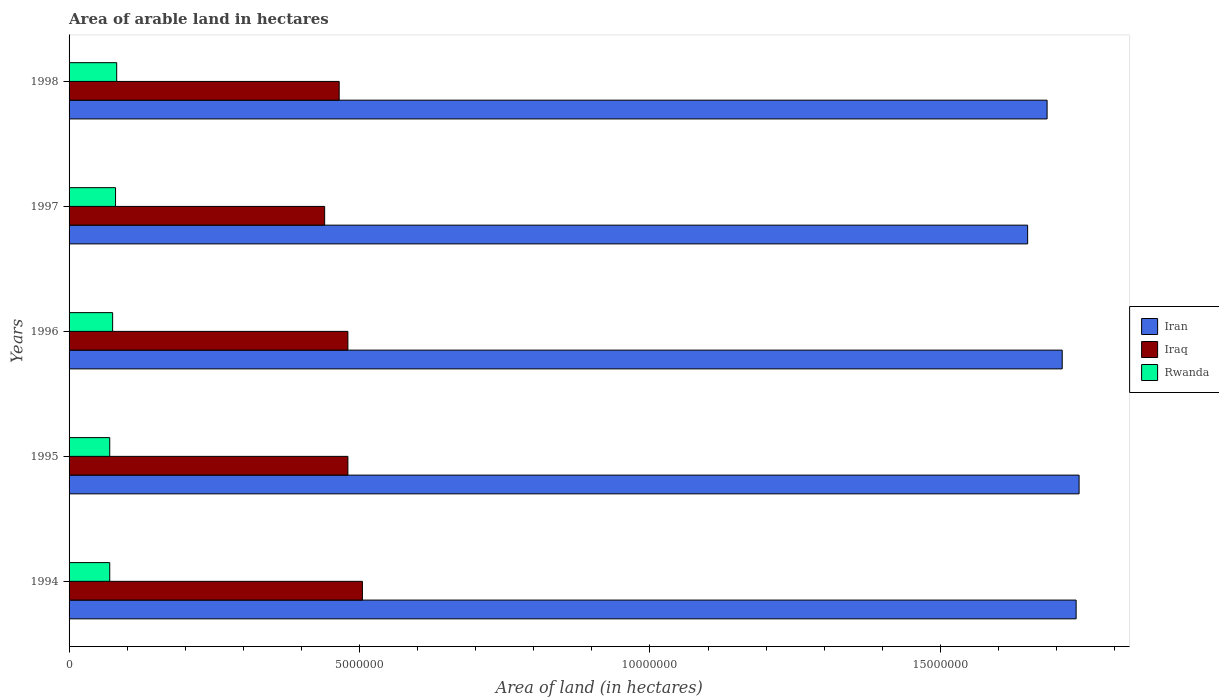How many different coloured bars are there?
Provide a short and direct response. 3. Are the number of bars per tick equal to the number of legend labels?
Offer a terse response. Yes. How many bars are there on the 2nd tick from the top?
Provide a short and direct response. 3. How many bars are there on the 5th tick from the bottom?
Keep it short and to the point. 3. In how many cases, is the number of bars for a given year not equal to the number of legend labels?
Ensure brevity in your answer.  0. What is the total arable land in Iraq in 1996?
Provide a short and direct response. 4.80e+06. Across all years, what is the maximum total arable land in Rwanda?
Make the answer very short. 8.20e+05. Across all years, what is the minimum total arable land in Iraq?
Provide a short and direct response. 4.40e+06. In which year was the total arable land in Iraq minimum?
Offer a very short reply. 1997. What is the total total arable land in Iraq in the graph?
Offer a very short reply. 2.37e+07. What is the difference between the total arable land in Rwanda in 1995 and that in 1997?
Your answer should be compact. -1.00e+05. What is the difference between the total arable land in Iraq in 1996 and the total arable land in Rwanda in 1997?
Provide a succinct answer. 4.00e+06. What is the average total arable land in Rwanda per year?
Your answer should be very brief. 7.54e+05. In the year 1997, what is the difference between the total arable land in Rwanda and total arable land in Iran?
Your answer should be very brief. -1.57e+07. In how many years, is the total arable land in Rwanda greater than 10000000 hectares?
Give a very brief answer. 0. Is the total arable land in Iraq in 1994 less than that in 1997?
Give a very brief answer. No. Is the difference between the total arable land in Rwanda in 1995 and 1998 greater than the difference between the total arable land in Iran in 1995 and 1998?
Your response must be concise. No. What is the difference between the highest and the lowest total arable land in Rwanda?
Provide a succinct answer. 1.20e+05. In how many years, is the total arable land in Iraq greater than the average total arable land in Iraq taken over all years?
Provide a succinct answer. 3. Is the sum of the total arable land in Iraq in 1994 and 1995 greater than the maximum total arable land in Rwanda across all years?
Keep it short and to the point. Yes. What does the 1st bar from the top in 1998 represents?
Your answer should be compact. Rwanda. What does the 2nd bar from the bottom in 1997 represents?
Offer a terse response. Iraq. Does the graph contain any zero values?
Provide a short and direct response. No. Does the graph contain grids?
Keep it short and to the point. No. What is the title of the graph?
Keep it short and to the point. Area of arable land in hectares. Does "Belgium" appear as one of the legend labels in the graph?
Ensure brevity in your answer.  No. What is the label or title of the X-axis?
Your answer should be compact. Area of land (in hectares). What is the label or title of the Y-axis?
Provide a succinct answer. Years. What is the Area of land (in hectares) of Iran in 1994?
Offer a very short reply. 1.73e+07. What is the Area of land (in hectares) of Iraq in 1994?
Offer a very short reply. 5.05e+06. What is the Area of land (in hectares) of Iran in 1995?
Make the answer very short. 1.74e+07. What is the Area of land (in hectares) in Iraq in 1995?
Provide a succinct answer. 4.80e+06. What is the Area of land (in hectares) of Iran in 1996?
Keep it short and to the point. 1.71e+07. What is the Area of land (in hectares) of Iraq in 1996?
Provide a succinct answer. 4.80e+06. What is the Area of land (in hectares) of Rwanda in 1996?
Make the answer very short. 7.50e+05. What is the Area of land (in hectares) of Iran in 1997?
Your answer should be compact. 1.65e+07. What is the Area of land (in hectares) in Iraq in 1997?
Your answer should be very brief. 4.40e+06. What is the Area of land (in hectares) in Iran in 1998?
Your answer should be very brief. 1.68e+07. What is the Area of land (in hectares) of Iraq in 1998?
Keep it short and to the point. 4.65e+06. What is the Area of land (in hectares) in Rwanda in 1998?
Give a very brief answer. 8.20e+05. Across all years, what is the maximum Area of land (in hectares) of Iran?
Your response must be concise. 1.74e+07. Across all years, what is the maximum Area of land (in hectares) in Iraq?
Your response must be concise. 5.05e+06. Across all years, what is the maximum Area of land (in hectares) of Rwanda?
Ensure brevity in your answer.  8.20e+05. Across all years, what is the minimum Area of land (in hectares) in Iran?
Your answer should be very brief. 1.65e+07. Across all years, what is the minimum Area of land (in hectares) of Iraq?
Provide a short and direct response. 4.40e+06. What is the total Area of land (in hectares) of Iran in the graph?
Provide a succinct answer. 8.52e+07. What is the total Area of land (in hectares) in Iraq in the graph?
Ensure brevity in your answer.  2.37e+07. What is the total Area of land (in hectares) in Rwanda in the graph?
Ensure brevity in your answer.  3.77e+06. What is the difference between the Area of land (in hectares) in Iran in 1994 and that in 1995?
Keep it short and to the point. -5.10e+04. What is the difference between the Area of land (in hectares) in Rwanda in 1994 and that in 1995?
Provide a succinct answer. 0. What is the difference between the Area of land (in hectares) of Iran in 1994 and that in 1996?
Provide a succinct answer. 2.40e+05. What is the difference between the Area of land (in hectares) in Iraq in 1994 and that in 1996?
Make the answer very short. 2.50e+05. What is the difference between the Area of land (in hectares) of Iran in 1994 and that in 1997?
Keep it short and to the point. 8.35e+05. What is the difference between the Area of land (in hectares) of Iraq in 1994 and that in 1997?
Keep it short and to the point. 6.50e+05. What is the difference between the Area of land (in hectares) in Iran in 1994 and that in 1998?
Provide a short and direct response. 5.00e+05. What is the difference between the Area of land (in hectares) of Iraq in 1994 and that in 1998?
Your answer should be compact. 4.00e+05. What is the difference between the Area of land (in hectares) in Iran in 1995 and that in 1996?
Keep it short and to the point. 2.91e+05. What is the difference between the Area of land (in hectares) in Iraq in 1995 and that in 1996?
Provide a succinct answer. 0. What is the difference between the Area of land (in hectares) in Rwanda in 1995 and that in 1996?
Provide a succinct answer. -5.00e+04. What is the difference between the Area of land (in hectares) of Iran in 1995 and that in 1997?
Your answer should be compact. 8.86e+05. What is the difference between the Area of land (in hectares) of Rwanda in 1995 and that in 1997?
Your answer should be compact. -1.00e+05. What is the difference between the Area of land (in hectares) of Iran in 1995 and that in 1998?
Offer a terse response. 5.51e+05. What is the difference between the Area of land (in hectares) in Iraq in 1995 and that in 1998?
Make the answer very short. 1.50e+05. What is the difference between the Area of land (in hectares) of Iran in 1996 and that in 1997?
Offer a very short reply. 5.95e+05. What is the difference between the Area of land (in hectares) in Iraq in 1996 and that in 1997?
Provide a short and direct response. 4.00e+05. What is the difference between the Area of land (in hectares) of Iran in 1996 and that in 1998?
Provide a succinct answer. 2.60e+05. What is the difference between the Area of land (in hectares) of Iran in 1997 and that in 1998?
Make the answer very short. -3.35e+05. What is the difference between the Area of land (in hectares) of Iran in 1994 and the Area of land (in hectares) of Iraq in 1995?
Give a very brief answer. 1.25e+07. What is the difference between the Area of land (in hectares) of Iran in 1994 and the Area of land (in hectares) of Rwanda in 1995?
Make the answer very short. 1.66e+07. What is the difference between the Area of land (in hectares) of Iraq in 1994 and the Area of land (in hectares) of Rwanda in 1995?
Make the answer very short. 4.35e+06. What is the difference between the Area of land (in hectares) in Iran in 1994 and the Area of land (in hectares) in Iraq in 1996?
Provide a succinct answer. 1.25e+07. What is the difference between the Area of land (in hectares) of Iran in 1994 and the Area of land (in hectares) of Rwanda in 1996?
Ensure brevity in your answer.  1.66e+07. What is the difference between the Area of land (in hectares) in Iraq in 1994 and the Area of land (in hectares) in Rwanda in 1996?
Provide a succinct answer. 4.30e+06. What is the difference between the Area of land (in hectares) of Iran in 1994 and the Area of land (in hectares) of Iraq in 1997?
Your answer should be very brief. 1.29e+07. What is the difference between the Area of land (in hectares) of Iran in 1994 and the Area of land (in hectares) of Rwanda in 1997?
Offer a terse response. 1.65e+07. What is the difference between the Area of land (in hectares) in Iraq in 1994 and the Area of land (in hectares) in Rwanda in 1997?
Offer a very short reply. 4.25e+06. What is the difference between the Area of land (in hectares) of Iran in 1994 and the Area of land (in hectares) of Iraq in 1998?
Your response must be concise. 1.27e+07. What is the difference between the Area of land (in hectares) of Iran in 1994 and the Area of land (in hectares) of Rwanda in 1998?
Your answer should be compact. 1.65e+07. What is the difference between the Area of land (in hectares) in Iraq in 1994 and the Area of land (in hectares) in Rwanda in 1998?
Your response must be concise. 4.23e+06. What is the difference between the Area of land (in hectares) in Iran in 1995 and the Area of land (in hectares) in Iraq in 1996?
Offer a terse response. 1.26e+07. What is the difference between the Area of land (in hectares) in Iran in 1995 and the Area of land (in hectares) in Rwanda in 1996?
Your answer should be compact. 1.66e+07. What is the difference between the Area of land (in hectares) in Iraq in 1995 and the Area of land (in hectares) in Rwanda in 1996?
Provide a short and direct response. 4.05e+06. What is the difference between the Area of land (in hectares) of Iran in 1995 and the Area of land (in hectares) of Iraq in 1997?
Offer a very short reply. 1.30e+07. What is the difference between the Area of land (in hectares) in Iran in 1995 and the Area of land (in hectares) in Rwanda in 1997?
Ensure brevity in your answer.  1.66e+07. What is the difference between the Area of land (in hectares) of Iran in 1995 and the Area of land (in hectares) of Iraq in 1998?
Your answer should be very brief. 1.27e+07. What is the difference between the Area of land (in hectares) of Iran in 1995 and the Area of land (in hectares) of Rwanda in 1998?
Your response must be concise. 1.66e+07. What is the difference between the Area of land (in hectares) in Iraq in 1995 and the Area of land (in hectares) in Rwanda in 1998?
Offer a terse response. 3.98e+06. What is the difference between the Area of land (in hectares) in Iran in 1996 and the Area of land (in hectares) in Iraq in 1997?
Provide a short and direct response. 1.27e+07. What is the difference between the Area of land (in hectares) in Iran in 1996 and the Area of land (in hectares) in Rwanda in 1997?
Offer a very short reply. 1.63e+07. What is the difference between the Area of land (in hectares) of Iran in 1996 and the Area of land (in hectares) of Iraq in 1998?
Provide a short and direct response. 1.24e+07. What is the difference between the Area of land (in hectares) of Iran in 1996 and the Area of land (in hectares) of Rwanda in 1998?
Make the answer very short. 1.63e+07. What is the difference between the Area of land (in hectares) in Iraq in 1996 and the Area of land (in hectares) in Rwanda in 1998?
Offer a very short reply. 3.98e+06. What is the difference between the Area of land (in hectares) in Iran in 1997 and the Area of land (in hectares) in Iraq in 1998?
Your answer should be compact. 1.19e+07. What is the difference between the Area of land (in hectares) in Iran in 1997 and the Area of land (in hectares) in Rwanda in 1998?
Your response must be concise. 1.57e+07. What is the difference between the Area of land (in hectares) of Iraq in 1997 and the Area of land (in hectares) of Rwanda in 1998?
Provide a succinct answer. 3.58e+06. What is the average Area of land (in hectares) of Iran per year?
Your answer should be very brief. 1.70e+07. What is the average Area of land (in hectares) of Iraq per year?
Provide a succinct answer. 4.74e+06. What is the average Area of land (in hectares) of Rwanda per year?
Offer a terse response. 7.54e+05. In the year 1994, what is the difference between the Area of land (in hectares) in Iran and Area of land (in hectares) in Iraq?
Ensure brevity in your answer.  1.23e+07. In the year 1994, what is the difference between the Area of land (in hectares) of Iran and Area of land (in hectares) of Rwanda?
Make the answer very short. 1.66e+07. In the year 1994, what is the difference between the Area of land (in hectares) in Iraq and Area of land (in hectares) in Rwanda?
Your answer should be very brief. 4.35e+06. In the year 1995, what is the difference between the Area of land (in hectares) of Iran and Area of land (in hectares) of Iraq?
Your response must be concise. 1.26e+07. In the year 1995, what is the difference between the Area of land (in hectares) of Iran and Area of land (in hectares) of Rwanda?
Provide a succinct answer. 1.67e+07. In the year 1995, what is the difference between the Area of land (in hectares) of Iraq and Area of land (in hectares) of Rwanda?
Provide a short and direct response. 4.10e+06. In the year 1996, what is the difference between the Area of land (in hectares) of Iran and Area of land (in hectares) of Iraq?
Ensure brevity in your answer.  1.23e+07. In the year 1996, what is the difference between the Area of land (in hectares) of Iran and Area of land (in hectares) of Rwanda?
Your answer should be very brief. 1.63e+07. In the year 1996, what is the difference between the Area of land (in hectares) in Iraq and Area of land (in hectares) in Rwanda?
Provide a short and direct response. 4.05e+06. In the year 1997, what is the difference between the Area of land (in hectares) in Iran and Area of land (in hectares) in Iraq?
Your answer should be very brief. 1.21e+07. In the year 1997, what is the difference between the Area of land (in hectares) of Iran and Area of land (in hectares) of Rwanda?
Your answer should be compact. 1.57e+07. In the year 1997, what is the difference between the Area of land (in hectares) of Iraq and Area of land (in hectares) of Rwanda?
Offer a very short reply. 3.60e+06. In the year 1998, what is the difference between the Area of land (in hectares) of Iran and Area of land (in hectares) of Iraq?
Give a very brief answer. 1.22e+07. In the year 1998, what is the difference between the Area of land (in hectares) of Iran and Area of land (in hectares) of Rwanda?
Give a very brief answer. 1.60e+07. In the year 1998, what is the difference between the Area of land (in hectares) in Iraq and Area of land (in hectares) in Rwanda?
Give a very brief answer. 3.83e+06. What is the ratio of the Area of land (in hectares) of Iraq in 1994 to that in 1995?
Your response must be concise. 1.05. What is the ratio of the Area of land (in hectares) of Iran in 1994 to that in 1996?
Offer a very short reply. 1.01. What is the ratio of the Area of land (in hectares) of Iraq in 1994 to that in 1996?
Offer a very short reply. 1.05. What is the ratio of the Area of land (in hectares) in Iran in 1994 to that in 1997?
Keep it short and to the point. 1.05. What is the ratio of the Area of land (in hectares) in Iraq in 1994 to that in 1997?
Your answer should be compact. 1.15. What is the ratio of the Area of land (in hectares) in Iran in 1994 to that in 1998?
Offer a very short reply. 1.03. What is the ratio of the Area of land (in hectares) of Iraq in 1994 to that in 1998?
Offer a terse response. 1.09. What is the ratio of the Area of land (in hectares) of Rwanda in 1994 to that in 1998?
Your response must be concise. 0.85. What is the ratio of the Area of land (in hectares) in Iran in 1995 to that in 1996?
Offer a terse response. 1.02. What is the ratio of the Area of land (in hectares) in Iraq in 1995 to that in 1996?
Keep it short and to the point. 1. What is the ratio of the Area of land (in hectares) in Iran in 1995 to that in 1997?
Provide a succinct answer. 1.05. What is the ratio of the Area of land (in hectares) of Rwanda in 1995 to that in 1997?
Provide a succinct answer. 0.88. What is the ratio of the Area of land (in hectares) in Iran in 1995 to that in 1998?
Provide a short and direct response. 1.03. What is the ratio of the Area of land (in hectares) in Iraq in 1995 to that in 1998?
Your answer should be compact. 1.03. What is the ratio of the Area of land (in hectares) in Rwanda in 1995 to that in 1998?
Your answer should be compact. 0.85. What is the ratio of the Area of land (in hectares) in Iran in 1996 to that in 1997?
Your answer should be very brief. 1.04. What is the ratio of the Area of land (in hectares) in Iraq in 1996 to that in 1997?
Offer a very short reply. 1.09. What is the ratio of the Area of land (in hectares) in Rwanda in 1996 to that in 1997?
Your answer should be compact. 0.94. What is the ratio of the Area of land (in hectares) of Iran in 1996 to that in 1998?
Your answer should be compact. 1.02. What is the ratio of the Area of land (in hectares) in Iraq in 1996 to that in 1998?
Provide a short and direct response. 1.03. What is the ratio of the Area of land (in hectares) in Rwanda in 1996 to that in 1998?
Offer a very short reply. 0.91. What is the ratio of the Area of land (in hectares) of Iran in 1997 to that in 1998?
Ensure brevity in your answer.  0.98. What is the ratio of the Area of land (in hectares) in Iraq in 1997 to that in 1998?
Give a very brief answer. 0.95. What is the ratio of the Area of land (in hectares) in Rwanda in 1997 to that in 1998?
Keep it short and to the point. 0.98. What is the difference between the highest and the second highest Area of land (in hectares) of Iran?
Make the answer very short. 5.10e+04. What is the difference between the highest and the second highest Area of land (in hectares) of Iraq?
Provide a succinct answer. 2.50e+05. What is the difference between the highest and the lowest Area of land (in hectares) of Iran?
Offer a very short reply. 8.86e+05. What is the difference between the highest and the lowest Area of land (in hectares) of Iraq?
Your answer should be compact. 6.50e+05. 